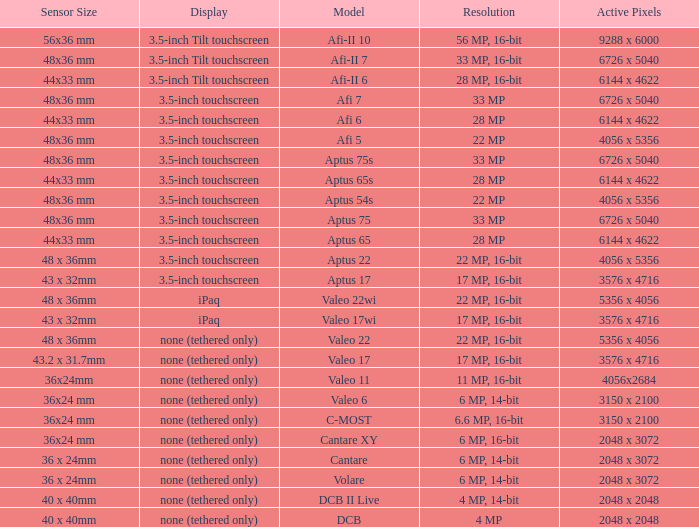What is the picture quality of the camera possessing 6726 x 5040 pixels and a model of afi 7? 33 MP. Parse the full table. {'header': ['Sensor Size', 'Display', 'Model', 'Resolution', 'Active Pixels'], 'rows': [['56x36 mm', '3.5-inch Tilt touchscreen', 'Afi-II 10', '56 MP, 16-bit', '9288 x 6000'], ['48x36 mm', '3.5-inch Tilt touchscreen', 'Afi-II 7', '33 MP, 16-bit', '6726 x 5040'], ['44x33 mm', '3.5-inch Tilt touchscreen', 'Afi-II 6', '28 MP, 16-bit', '6144 x 4622'], ['48x36 mm', '3.5-inch touchscreen', 'Afi 7', '33 MP', '6726 x 5040'], ['44x33 mm', '3.5-inch touchscreen', 'Afi 6', '28 MP', '6144 x 4622'], ['48x36 mm', '3.5-inch touchscreen', 'Afi 5', '22 MP', '4056 x 5356'], ['48x36 mm', '3.5-inch touchscreen', 'Aptus 75s', '33 MP', '6726 x 5040'], ['44x33 mm', '3.5-inch touchscreen', 'Aptus 65s', '28 MP', '6144 x 4622'], ['48x36 mm', '3.5-inch touchscreen', 'Aptus 54s', '22 MP', '4056 x 5356'], ['48x36 mm', '3.5-inch touchscreen', 'Aptus 75', '33 MP', '6726 x 5040'], ['44x33 mm', '3.5-inch touchscreen', 'Aptus 65', '28 MP', '6144 x 4622'], ['48 x 36mm', '3.5-inch touchscreen', 'Aptus 22', '22 MP, 16-bit', '4056 x 5356'], ['43 x 32mm', '3.5-inch touchscreen', 'Aptus 17', '17 MP, 16-bit', '3576 x 4716'], ['48 x 36mm', 'iPaq', 'Valeo 22wi', '22 MP, 16-bit', '5356 x 4056'], ['43 x 32mm', 'iPaq', 'Valeo 17wi', '17 MP, 16-bit', '3576 x 4716'], ['48 x 36mm', 'none (tethered only)', 'Valeo 22', '22 MP, 16-bit', '5356 x 4056'], ['43.2 x 31.7mm', 'none (tethered only)', 'Valeo 17', '17 MP, 16-bit', '3576 x 4716'], ['36x24mm', 'none (tethered only)', 'Valeo 11', '11 MP, 16-bit', '4056x2684'], ['36x24 mm', 'none (tethered only)', 'Valeo 6', '6 MP, 14-bit', '3150 x 2100'], ['36x24 mm', 'none (tethered only)', 'C-MOST', '6.6 MP, 16-bit', '3150 x 2100'], ['36x24 mm', 'none (tethered only)', 'Cantare XY', '6 MP, 16-bit', '2048 x 3072'], ['36 x 24mm', 'none (tethered only)', 'Cantare', '6 MP, 14-bit', '2048 x 3072'], ['36 x 24mm', 'none (tethered only)', 'Volare', '6 MP, 14-bit', '2048 x 3072'], ['40 x 40mm', 'none (tethered only)', 'DCB II Live', '4 MP, 14-bit', '2048 x 2048'], ['40 x 40mm', 'none (tethered only)', 'DCB', '4 MP', '2048 x 2048']]} 